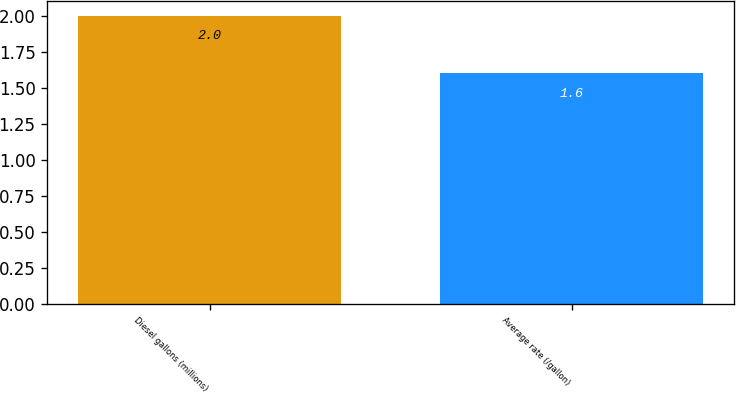Convert chart. <chart><loc_0><loc_0><loc_500><loc_500><bar_chart><fcel>Diesel gallons (millions)<fcel>Average rate (/gallon)<nl><fcel>2<fcel>1.6<nl></chart> 